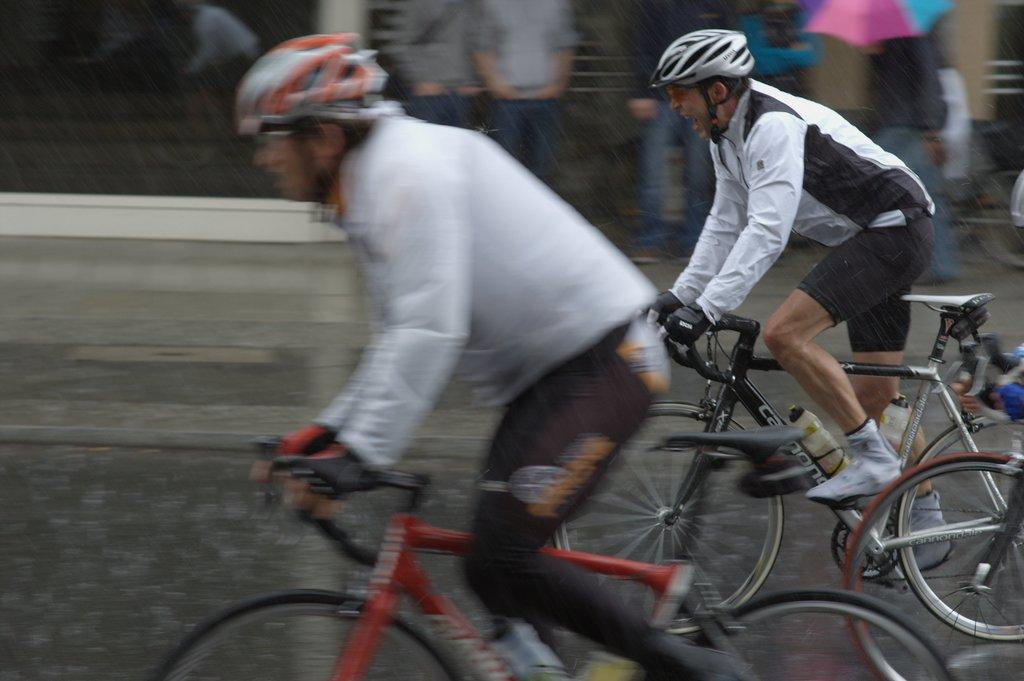What are the two people in the image doing? The two people in the image are riding bicycles. What can be seen in the background of the image? Many people are watching in the background. What is in the middle of the image? There is a road in the middle of the image. Can you describe any other features in the image? There is a window visible in the image. What type of knife is being used by the person in the image? There is no knife present in the image; the two people are riding bicycles. 